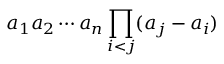Convert formula to latex. <formula><loc_0><loc_0><loc_500><loc_500>a _ { 1 } a _ { 2 } \cdots a _ { n } \prod _ { i < j } ( a _ { j } - a _ { i } )</formula> 